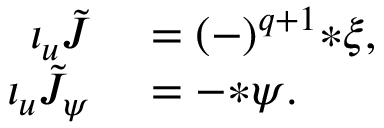<formula> <loc_0><loc_0><loc_500><loc_500>\begin{array} { r l } { \iota _ { u } \tilde { J } } & = ( - ) ^ { q + 1 } { * \xi } , } \\ { \iota _ { u } \tilde { J } _ { \psi } } & = - { * \psi } . } \end{array}</formula> 